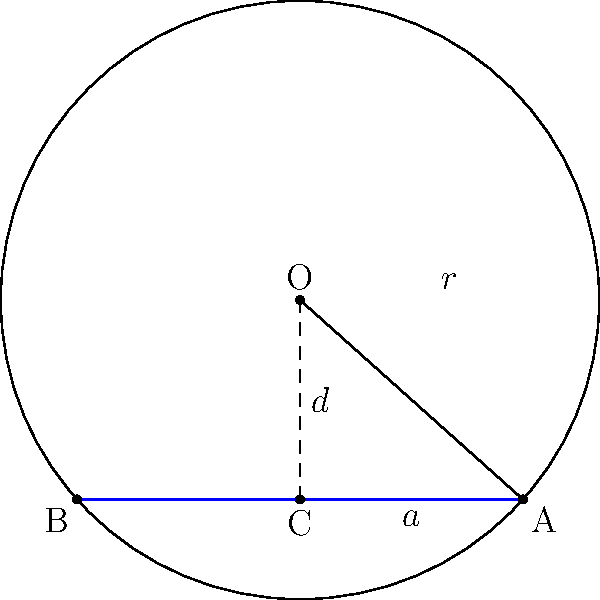In a circle with radius $r = 3$ cm, a chord AB is drawn such that the perpendicular distance from the center O to the chord is $d = 2$ cm. Calculate the length of the chord AB. Let's approach this step-by-step:

1) In the right-angled triangle OCA:
   - OC is the perpendicular distance from the center to the chord (given as $d = 2$ cm)
   - OA is the radius of the circle (given as $r = 3$ cm)
   - AC is half the length of the chord (let's call this $a$)

2) We can use the Pythagorean theorem in this right-angled triangle:

   $$OA^2 = OC^2 + AC^2$$

3) Substituting the known values:

   $$3^2 = 2^2 + a^2$$

4) Simplify:

   $$9 = 4 + a^2$$

5) Solve for $a$:

   $$a^2 = 9 - 4 = 5$$
   $$a = \sqrt{5}$$

6) Remember, $a$ is half the length of the chord. So the full length of the chord AB is:

   $$AB = 2a = 2\sqrt{5}$$

Therefore, the length of the chord AB is $2\sqrt{5}$ cm.
Answer: $2\sqrt{5}$ cm 